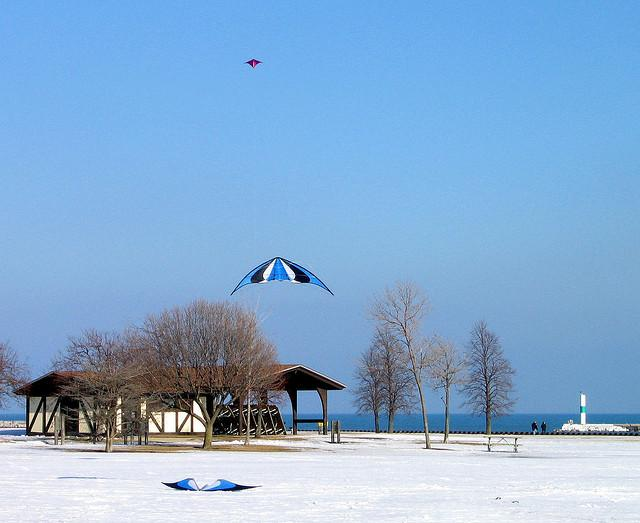The kites perform was motion in order to move across the sky?

Choices:
A) they jump
B) they skip
C) they glide
D) they catch they glide 